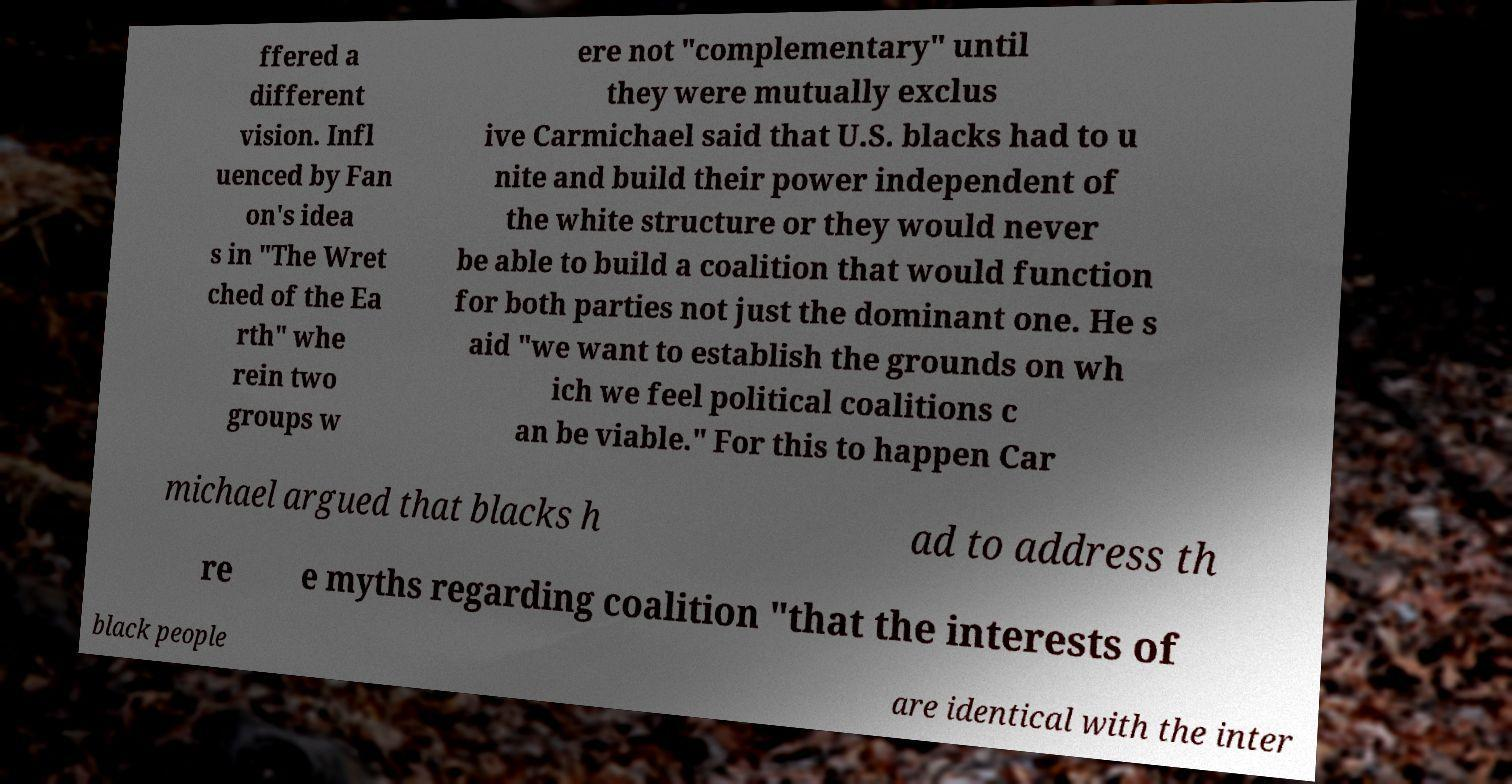For documentation purposes, I need the text within this image transcribed. Could you provide that? ffered a different vision. Infl uenced by Fan on's idea s in "The Wret ched of the Ea rth" whe rein two groups w ere not "complementary" until they were mutually exclus ive Carmichael said that U.S. blacks had to u nite and build their power independent of the white structure or they would never be able to build a coalition that would function for both parties not just the dominant one. He s aid "we want to establish the grounds on wh ich we feel political coalitions c an be viable." For this to happen Car michael argued that blacks h ad to address th re e myths regarding coalition "that the interests of black people are identical with the inter 